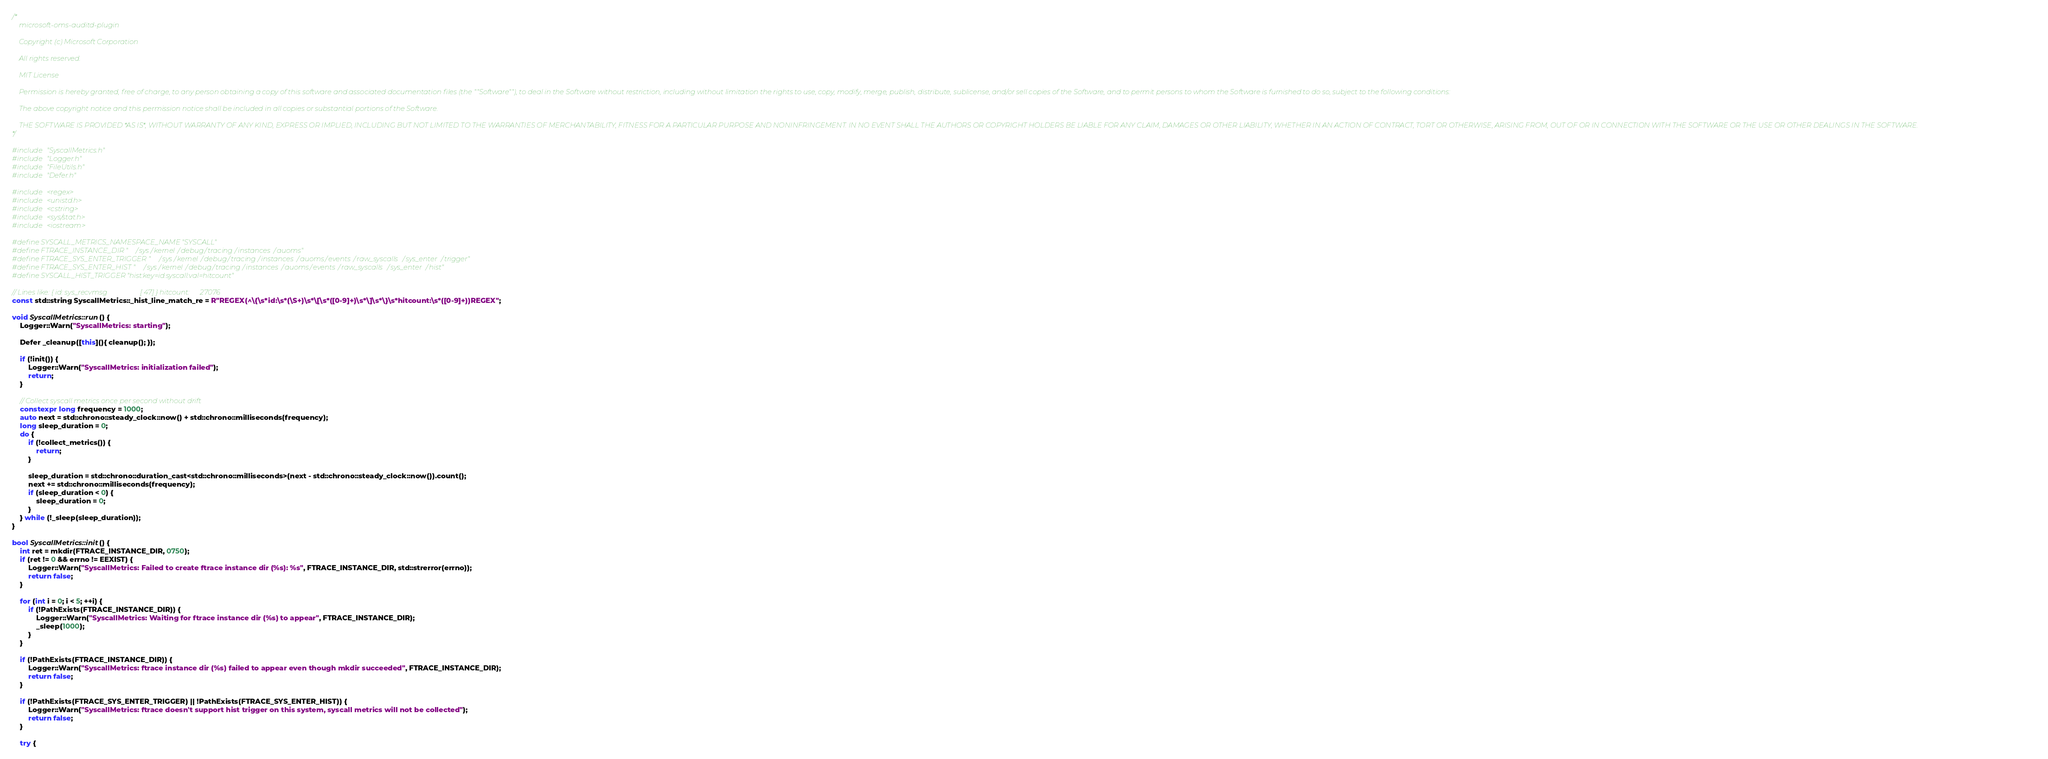<code> <loc_0><loc_0><loc_500><loc_500><_C++_>/*
    microsoft-oms-auditd-plugin

    Copyright (c) Microsoft Corporation

    All rights reserved.

    MIT License

    Permission is hereby granted, free of charge, to any person obtaining a copy of this software and associated documentation files (the ""Software""), to deal in the Software without restriction, including without limitation the rights to use, copy, modify, merge, publish, distribute, sublicense, and/or sell copies of the Software, and to permit persons to whom the Software is furnished to do so, subject to the following conditions:

    The above copyright notice and this permission notice shall be included in all copies or substantial portions of the Software.

    THE SOFTWARE IS PROVIDED *AS IS*, WITHOUT WARRANTY OF ANY KIND, EXPRESS OR IMPLIED, INCLUDING BUT NOT LIMITED TO THE WARRANTIES OF MERCHANTABILITY, FITNESS FOR A PARTICULAR PURPOSE AND NONINFRINGEMENT. IN NO EVENT SHALL THE AUTHORS OR COPYRIGHT HOLDERS BE LIABLE FOR ANY CLAIM, DAMAGES OR OTHER LIABILITY, WHETHER IN AN ACTION OF CONTRACT, TORT OR OTHERWISE, ARISING FROM, OUT OF OR IN CONNECTION WITH THE SOFTWARE OR THE USE OR OTHER DEALINGS IN THE SOFTWARE.
*/

#include "SyscallMetrics.h"
#include "Logger.h"
#include "FileUtils.h"
#include "Defer.h"

#include <regex>
#include <unistd.h>
#include <cstring>
#include <sys/stat.h>
#include <iostream>

#define SYSCALL_METRICS_NAMESPACE_NAME "SYSCALL"
#define FTRACE_INSTANCE_DIR "/sys/kernel/debug/tracing/instances/auoms"
#define FTRACE_SYS_ENTER_TRIGGER "/sys/kernel/debug/tracing/instances/auoms/events/raw_syscalls/sys_enter/trigger"
#define FTRACE_SYS_ENTER_HIST "/sys/kernel/debug/tracing/instances/auoms/events/raw_syscalls/sys_enter/hist"
#define SYSCALL_HIST_TRIGGER "hist:key=id.syscall:val=hitcount"

// Lines like: { id: sys_recvmsg                   [ 47] } hitcount:      27076
const std::string SyscallMetrics::_hist_line_match_re = R"REGEX(^\{\s*id:\s*(\S+)\s*\[\s*([0-9]+)\s*\]\s*\}\s*hitcount:\s*([0-9]+))REGEX";

void SyscallMetrics::run() {
    Logger::Warn("SyscallMetrics: starting");

    Defer _cleanup([this](){ cleanup(); });

    if (!init()) {
        Logger::Warn("SyscallMetrics: initialization failed");
        return;
    }

    // Collect syscall metrics once per second without drift
    constexpr long frequency = 1000;
    auto next = std::chrono::steady_clock::now() + std::chrono::milliseconds(frequency);
    long sleep_duration = 0;
    do {
        if (!collect_metrics()) {
            return;
        }

        sleep_duration = std::chrono::duration_cast<std::chrono::milliseconds>(next - std::chrono::steady_clock::now()).count();
        next += std::chrono::milliseconds(frequency);
        if (sleep_duration < 0) {
            sleep_duration = 0;
        }
    } while (!_sleep(sleep_duration));
}

bool SyscallMetrics::init() {
    int ret = mkdir(FTRACE_INSTANCE_DIR, 0750);
    if (ret != 0 && errno != EEXIST) {
        Logger::Warn("SyscallMetrics: Failed to create ftrace instance dir (%s): %s", FTRACE_INSTANCE_DIR, std::strerror(errno));
        return false;
    }

    for (int i = 0; i < 5; ++i) {
        if (!PathExists(FTRACE_INSTANCE_DIR)) {
            Logger::Warn("SyscallMetrics: Waiting for ftrace instance dir (%s) to appear", FTRACE_INSTANCE_DIR);
            _sleep(1000);
        }
    }

    if (!PathExists(FTRACE_INSTANCE_DIR)) {
        Logger::Warn("SyscallMetrics: ftrace instance dir (%s) failed to appear even though mkdir succeeded", FTRACE_INSTANCE_DIR);
        return false;
    }

    if (!PathExists(FTRACE_SYS_ENTER_TRIGGER) || !PathExists(FTRACE_SYS_ENTER_HIST)) {
        Logger::Warn("SyscallMetrics: ftrace doesn't support hist trigger on this system, syscall metrics will not be collected");
        return false;
    }

    try {</code> 